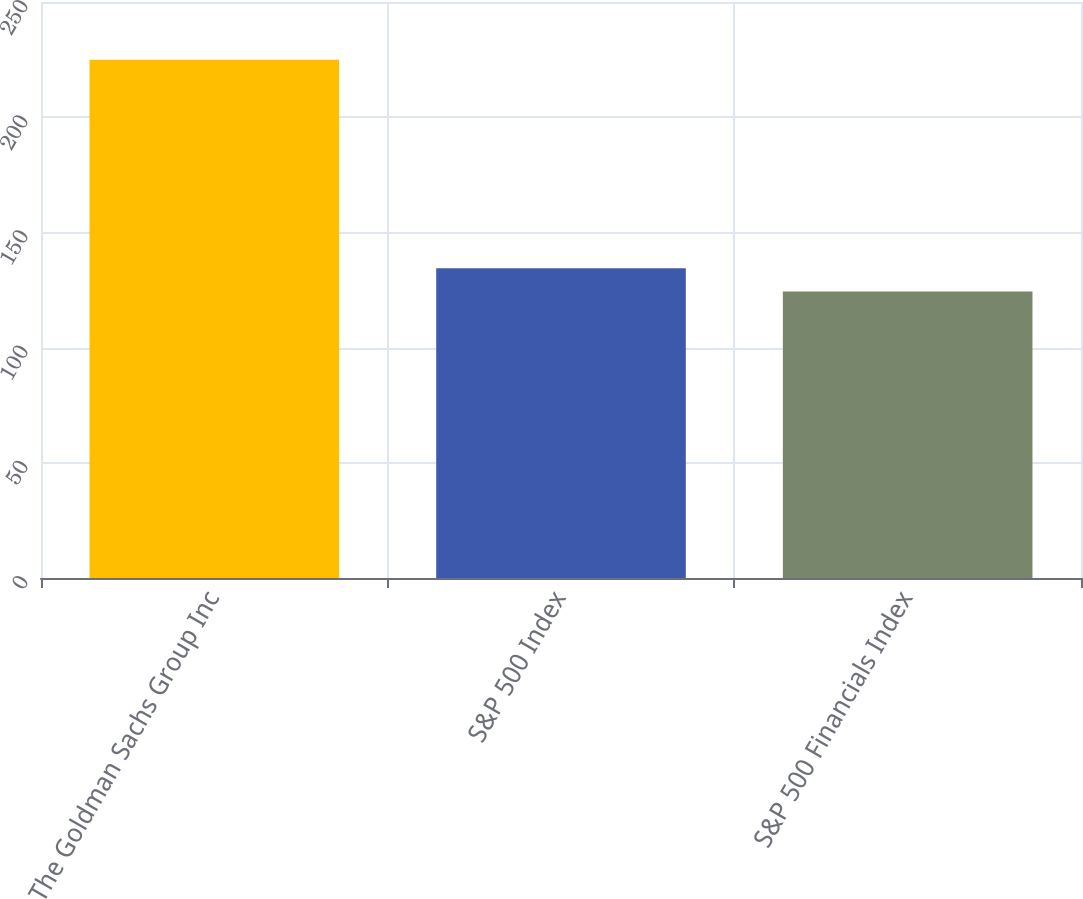<chart> <loc_0><loc_0><loc_500><loc_500><bar_chart><fcel>The Goldman Sachs Group Inc<fcel>S&P 500 Index<fcel>S&P 500 Financials Index<nl><fcel>224.98<fcel>134.44<fcel>124.38<nl></chart> 